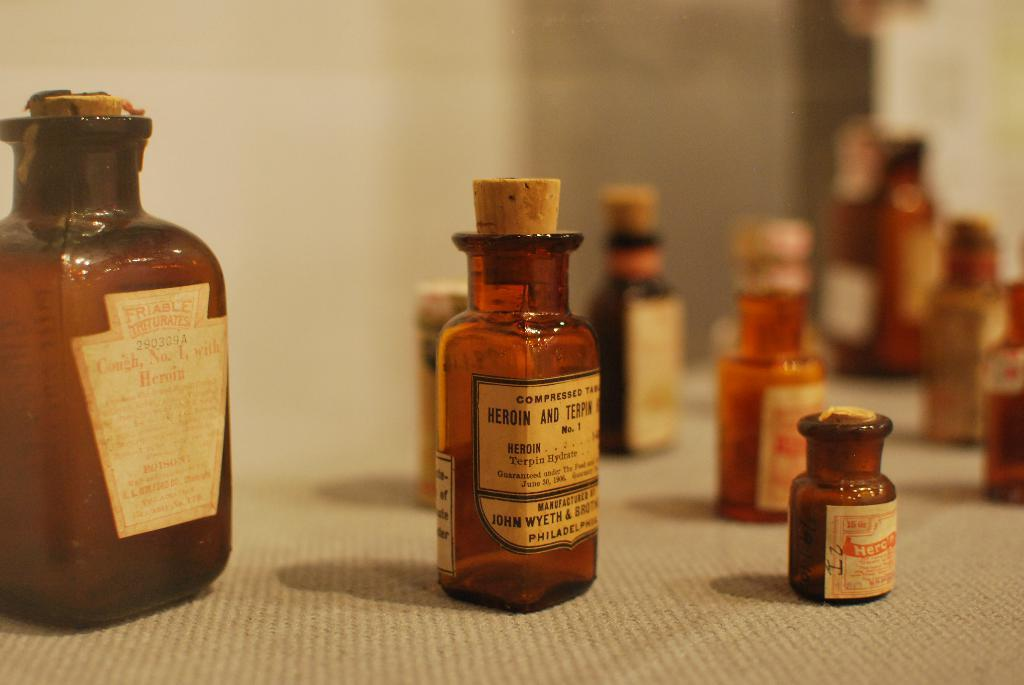Provide a one-sentence caption for the provided image. John Wyeth and Brothers manufactured heroin and terpin compressed tablets. 